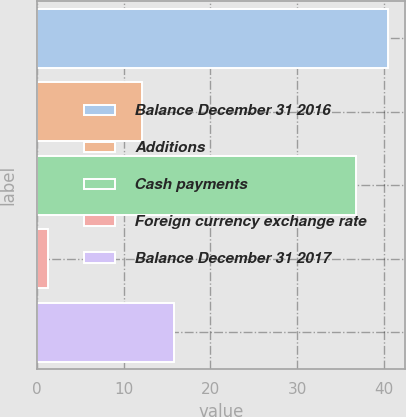Convert chart to OTSL. <chart><loc_0><loc_0><loc_500><loc_500><bar_chart><fcel>Balance December 31 2016<fcel>Additions<fcel>Cash payments<fcel>Foreign currency exchange rate<fcel>Balance December 31 2017<nl><fcel>40.38<fcel>12.1<fcel>36.7<fcel>1.3<fcel>15.78<nl></chart> 